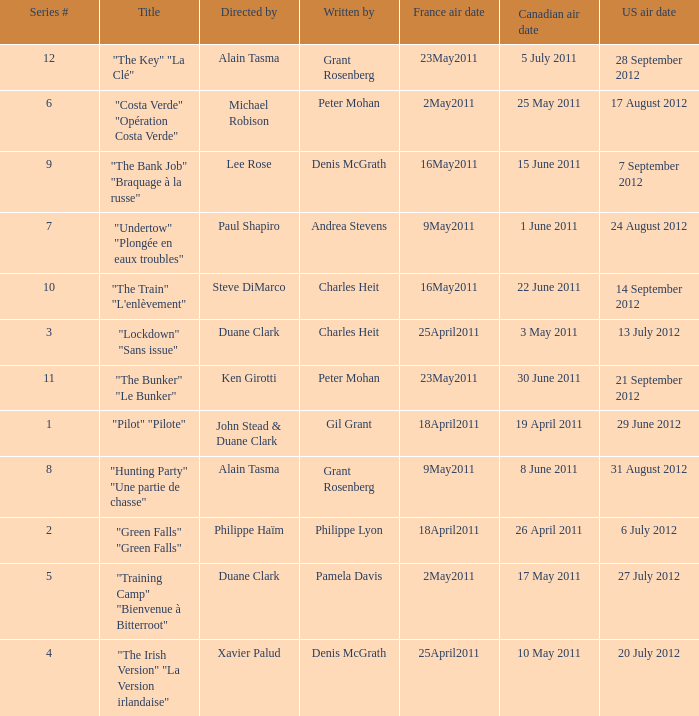What is the US air date when the director is ken girotti? 21 September 2012. 